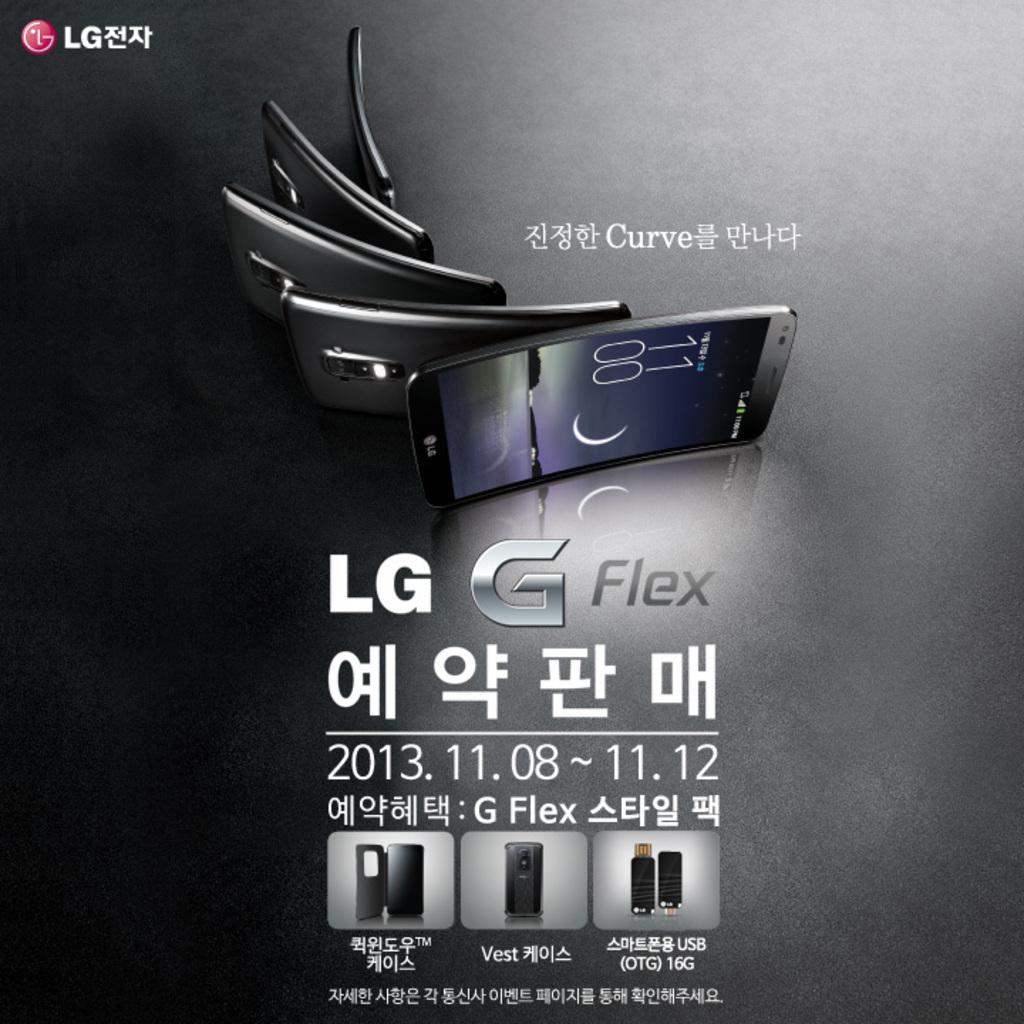What phone manufacture does this phone belong to?
Your response must be concise. Lg. What brand is this phone?
Your answer should be compact. Lg. 